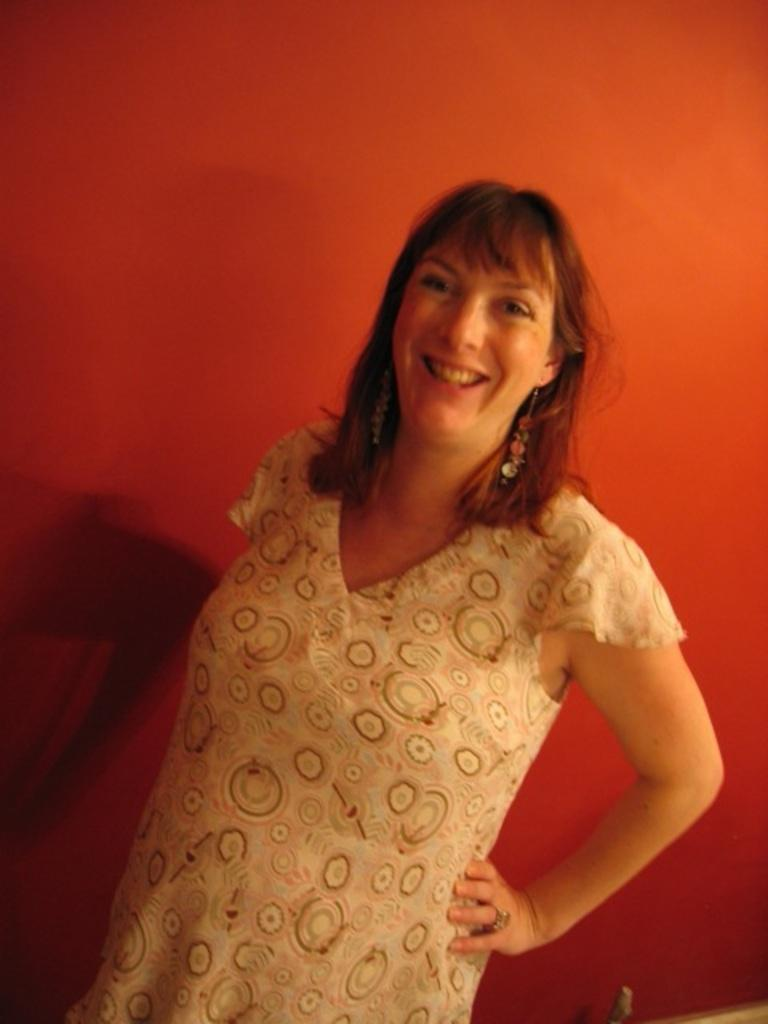Who is the main subject in the image? There is a lady in the center of the image. What can be seen in the background of the image? There is a wall in the background of the image. What type of butter is being used by the government in the image? There is no butter or government present in the image; it only features a lady and a wall in the background. 